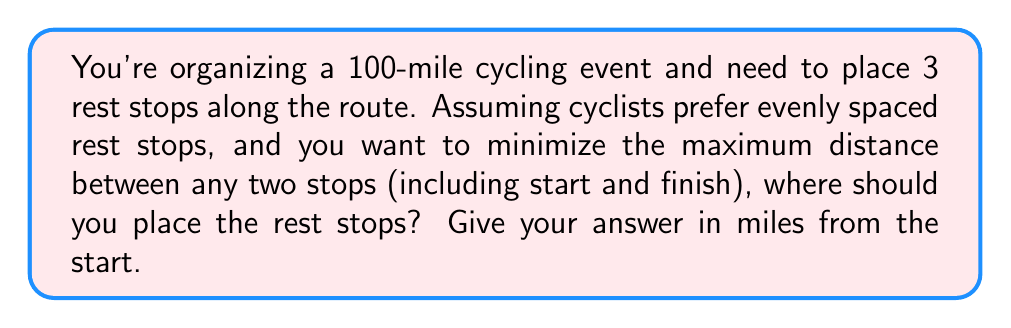Show me your answer to this math problem. To solve this problem, we can use a simple application of game theory concepts:

1. The goal is to minimize the maximum distance between any two stops.
2. With 3 rest stops, we effectively divide the route into 4 segments.
3. The optimal solution is when all segments are equal in length.

Let's calculate:

1. Total distance: 100 miles
2. Number of segments: 4
3. Length of each segment: $100 \div 4 = 25$ miles

Now, we can determine the location of each rest stop:

* First rest stop: $25$ miles
* Second rest stop: $50$ miles
* Third rest stop: $75$ miles

This solution ensures that no cyclist will ever be more than 25 miles from a rest stop or the start/finish line, which is the optimal placement for rider comfort and safety.

While this problem doesn't involve complex game theory, it illustrates the concept of minimizing the maximum disadvantage, which is a key principle in game theory and optimization problems.
Answer: The optimal placement of rest stops is at 25, 50, and 75 miles from the start. 